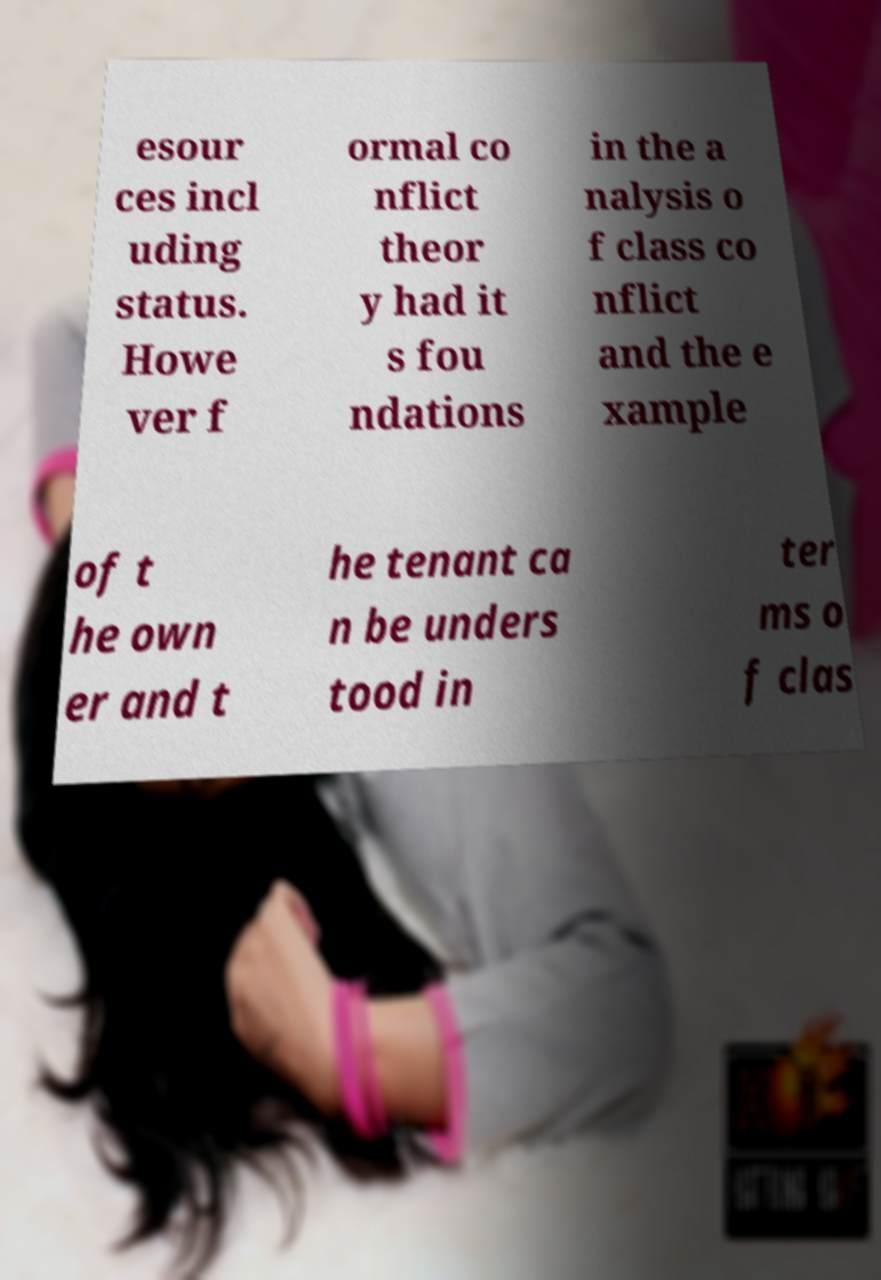What messages or text are displayed in this image? I need them in a readable, typed format. esour ces incl uding status. Howe ver f ormal co nflict theor y had it s fou ndations in the a nalysis o f class co nflict and the e xample of t he own er and t he tenant ca n be unders tood in ter ms o f clas 